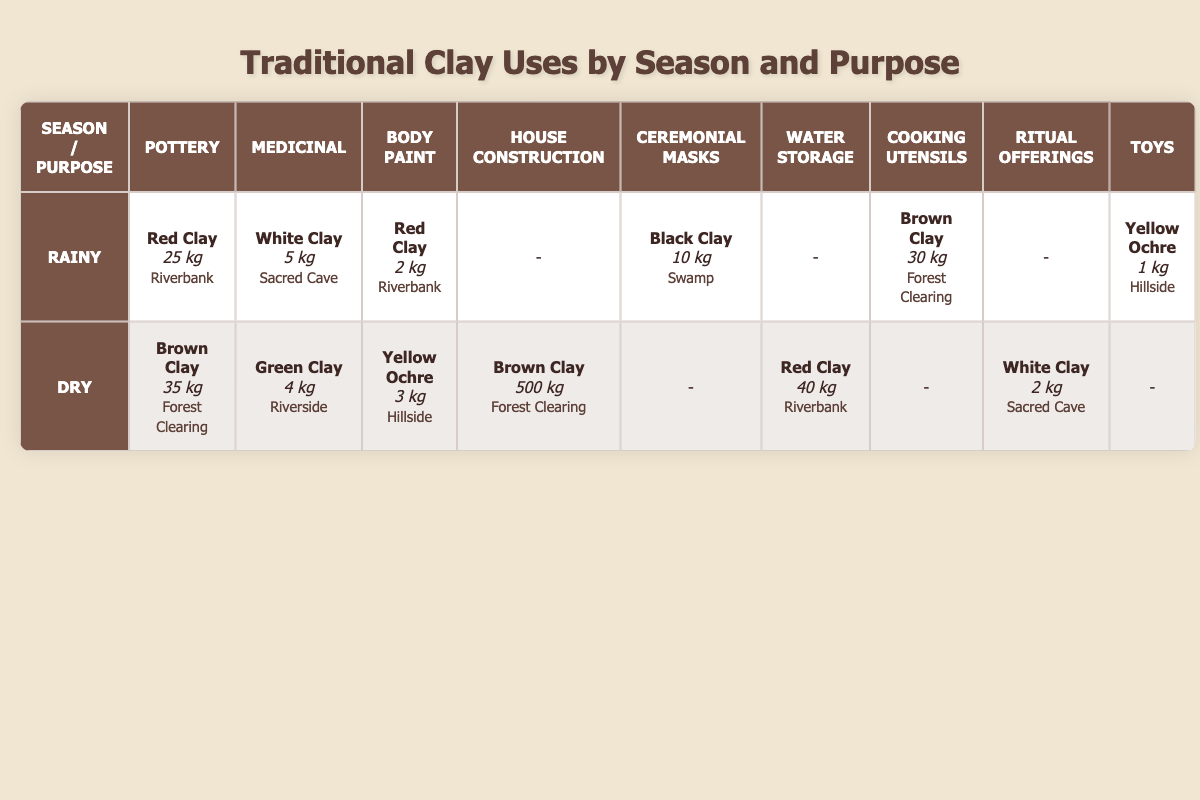What type of clay is used for pottery in the rainy season? In the table under the rainy season and the pottery purpose, the clay type listed is Red Clay, with a quantity of 25 kg from the Riverbank.
Answer: Red Clay How much clay is used for cooking utensils in the rainy season? The table shows that for cooking utensils in the rainy season, Brown Clay is used, amounting to 30 kg from the Forest Clearing.
Answer: 30 kg Is Green Clay used in the rainy season? The table does not have any entries for Green Clay under the rainy season, indicating that it is not used at that time.
Answer: No What is the total quantity of clay used for body paint across both seasons? For body paint, 2 kg of Red Clay is used in the rainy season and 3 kg of Yellow Ochre in the dry season. Adding these together gives 2 kg + 3 kg = 5 kg total.
Answer: 5 kg In which location is the highest quantity of clay used for house construction found? The table lists 500 kg of Brown Clay for house construction during the dry season, from the Forest Clearing, which is higher than any other entries for this purpose.
Answer: Forest Clearing Which clay type has the least quantity used for toys across both seasons? For the rainy season, 1 kg of Yellow Ochre is used for toys. Since there are no entries for toys in the dry season, this is the least quantity overall.
Answer: Yellow Ochre Are there any medicinal uses for clay during the dry season? Yes, the table indicates that 4 kg of Green Clay is used for medicinal purposes in the dry season, confirming that there is a medicinal use during that time.
Answer: Yes What is the difference in quantity of Red Clay used for water storage in the dry season compared to pottery in the rainy season? In the dry season, 40 kg of Red Clay is used for water storage, while in the rainy season, 25 kg is used for pottery. The difference is 40 kg - 25 kg = 15 kg.
Answer: 15 kg How many purposes are served by White Clay during rainy and dry seasons combined? The table shows that White Clay serves two purposes: 5 kg for medicinal in the rainy season and 2 kg for ritual offerings in the dry season, making a total of 2 purposes overall.
Answer: 2 purposes 